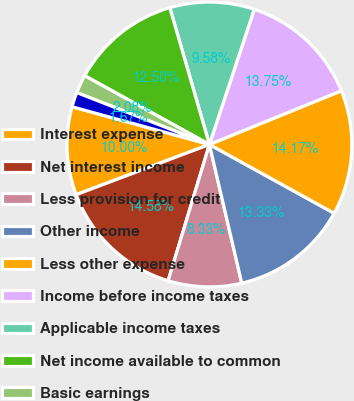Convert chart to OTSL. <chart><loc_0><loc_0><loc_500><loc_500><pie_chart><fcel>Interest expense<fcel>Net interest income<fcel>Less provision for credit<fcel>Other income<fcel>Less other expense<fcel>Income before income taxes<fcel>Applicable income taxes<fcel>Net income available to common<fcel>Basic earnings<fcel>Diluted earnings<nl><fcel>10.0%<fcel>14.58%<fcel>8.33%<fcel>13.33%<fcel>14.17%<fcel>13.75%<fcel>9.58%<fcel>12.5%<fcel>2.08%<fcel>1.67%<nl></chart> 